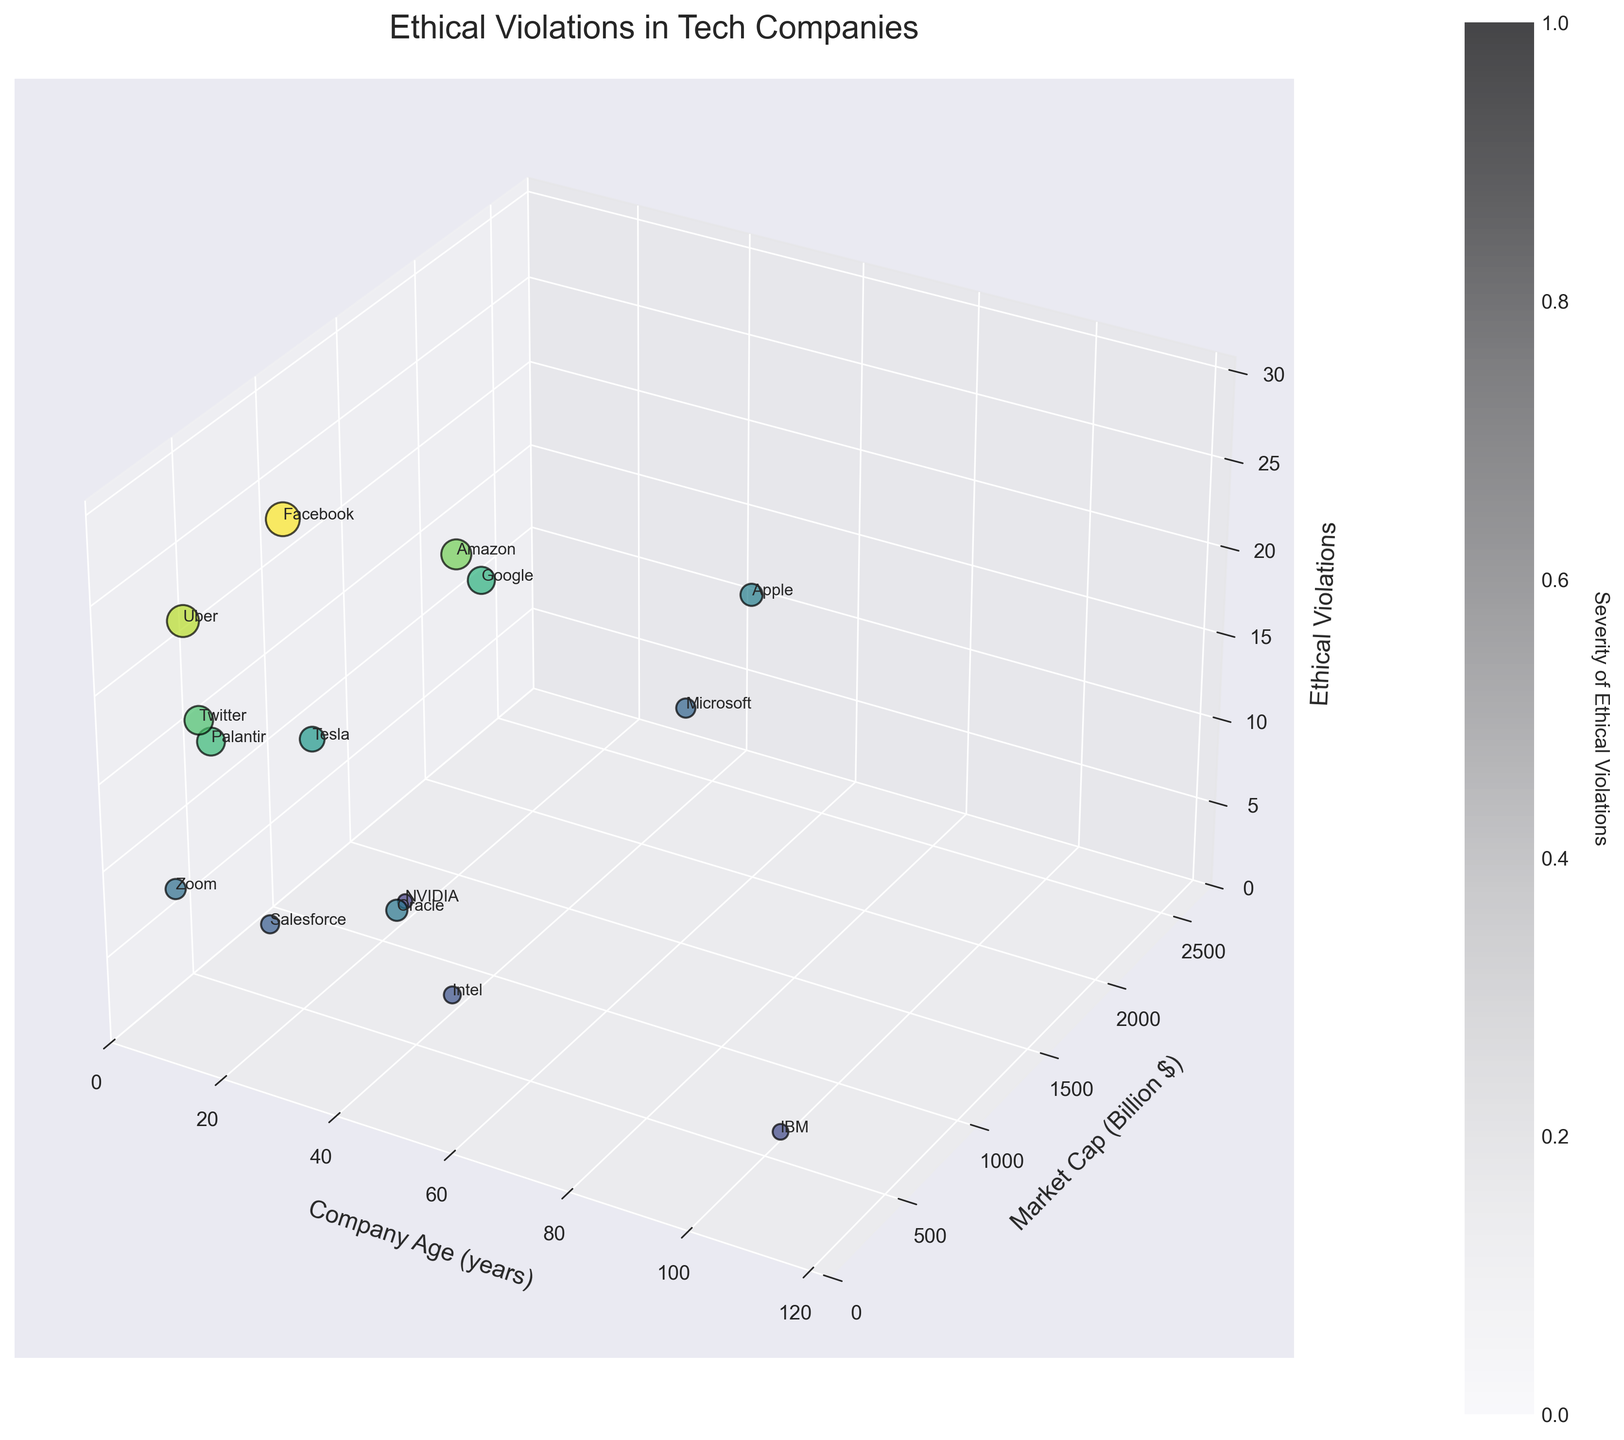What is the title of the 3D plot? The title of the plot is usually displayed at the top of the figure. It provides a summary of what the plot represents. In this case, the title is “Ethical Violations in Tech Companies.”
Answer: Ethical Violations in Tech Companies Which company has the highest number of ethical violations? Look for the point on the Z-axis with the maximum value. The point with the highest Z-value represents the company with the most ethical violations. In this figure, it’s Facebook with 28 violations.
Answer: Facebook How many companies are represented in the plot? Count the number of data points or annotations with company names. Each data point corresponds to a company. In this plot, there are 15 companies.
Answer: 15 Does any company with a market capitalization over $1000 billion have fewer than 10 ethical violations? Locate companies with a Y-value over 1000 on the Market Cap axis and check their Z-values for ethical violations. Here, both Apple (12 violations) and Microsoft (9 violations) have market capitalizations over $1000 billion, but only Microsoft has fewer than 10 violations.
Answer: Yes Which industry subsector includes companies with the highest ethical violations, and what are those companies? Identify the companies with the highest points on the Z-axis and note their industry subsectors. Facebook (Social Media) and Amazon (E-commerce) have the highest ethical violations.
Answer: Social Media (Facebook), E-commerce (Amazon) Do older companies tend to have more or fewer ethical violations compared to newer companies? To determine this trend, observe the Z-values in relation to the X-values for company age. Generally, older companies like IBM and Intel have fewer violations, while younger companies like Facebook and Uber have more violations.
Answer: Older companies tend to have fewer violations Between Google and Amazon, which company has a higher number of ethical violations? Compare the Z-values of the points labeled Google and Amazon. Google has a Z-value of 18 while Amazon has 22, so Amazon has a higher number of violations.
Answer: Amazon In the CRM Software industry subsector, what is the company and its number of ethical violations? Identify the data point labeled Salesforce (the recognized CRM Software company) by locating its label in the plot and observing its Z-value. Salesforce has 8 ethical violations.
Answer: Salesforce, 8 Which company has the lowest market capitalization and how many ethical violations does it have? Look for the data point with the lowest Y-value (market capitalization) and read its Z-value. Palantir, with a market capitalization of $40 billion, has 19 ethical violations.
Answer: Palantir, 19 What is the relationship between market capitalization and ethical violations for the e-commerce industry subsector? Identify Amazon (the known e-commerce company) and observe its coordinates. Amazon has a relatively high market cap and also a high number of ethical violations, indicating a potential positive correlation in this specific subsector.
Answer: Positive correlation 